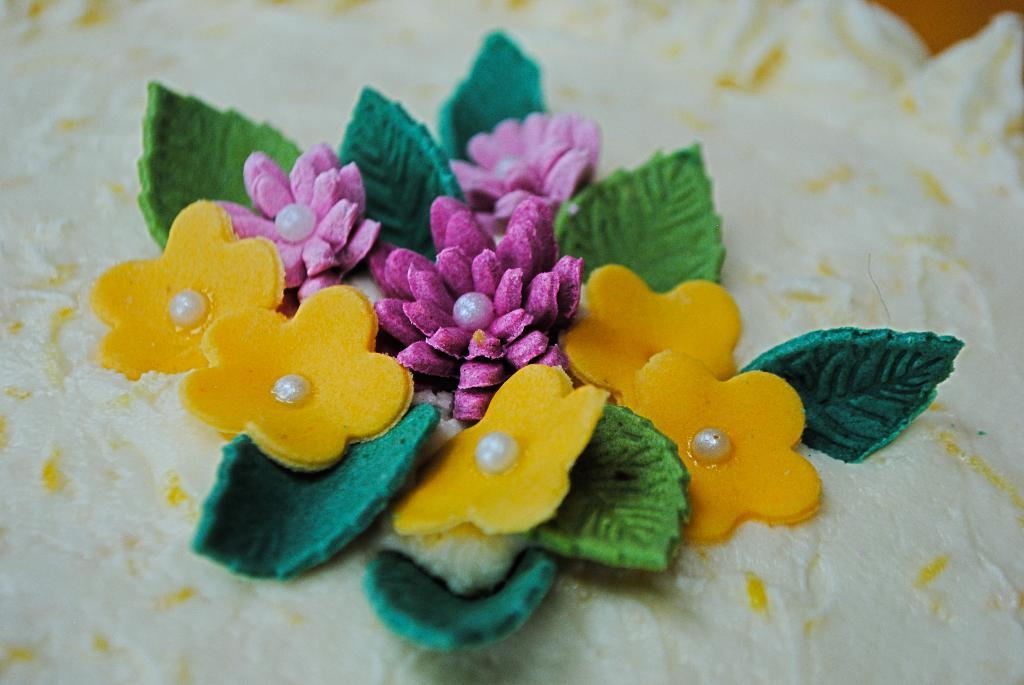What is the main subject of the image? The main subject of the image is a material. What type of decorations are present on the material? The material has artificial flowers and artificial leaves. What type of company is depicted in the image? There is no company depicted in the image; it features a material with artificial flowers and leaves. What sound can be heard coming from the artificial flowers in the image? There is no sound present in the image, as it is a still image of a material with artificial flowers and leaves. 